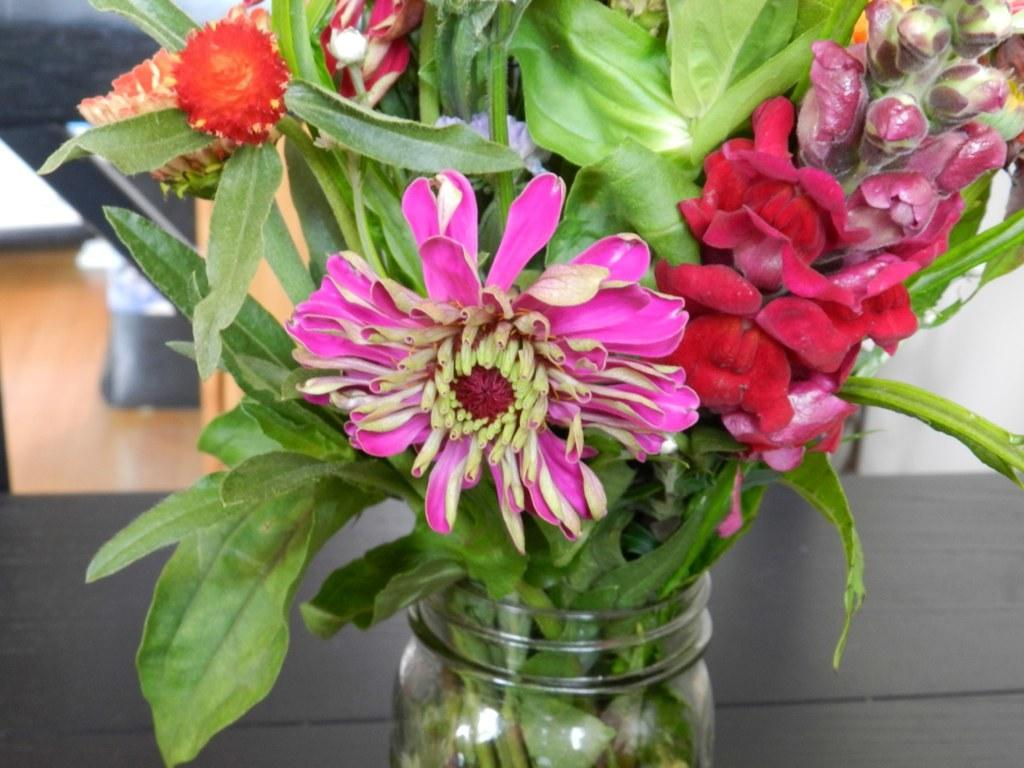What object is placed on the table in the image? There is a flower vase on a table in the image. Can you describe the background of the image? The background of the image is blurred. What role does the partner play in the image? There is no partner present in the image. What action is being performed by the object in the image? The object in the image, the flower vase, is not performing any action. 